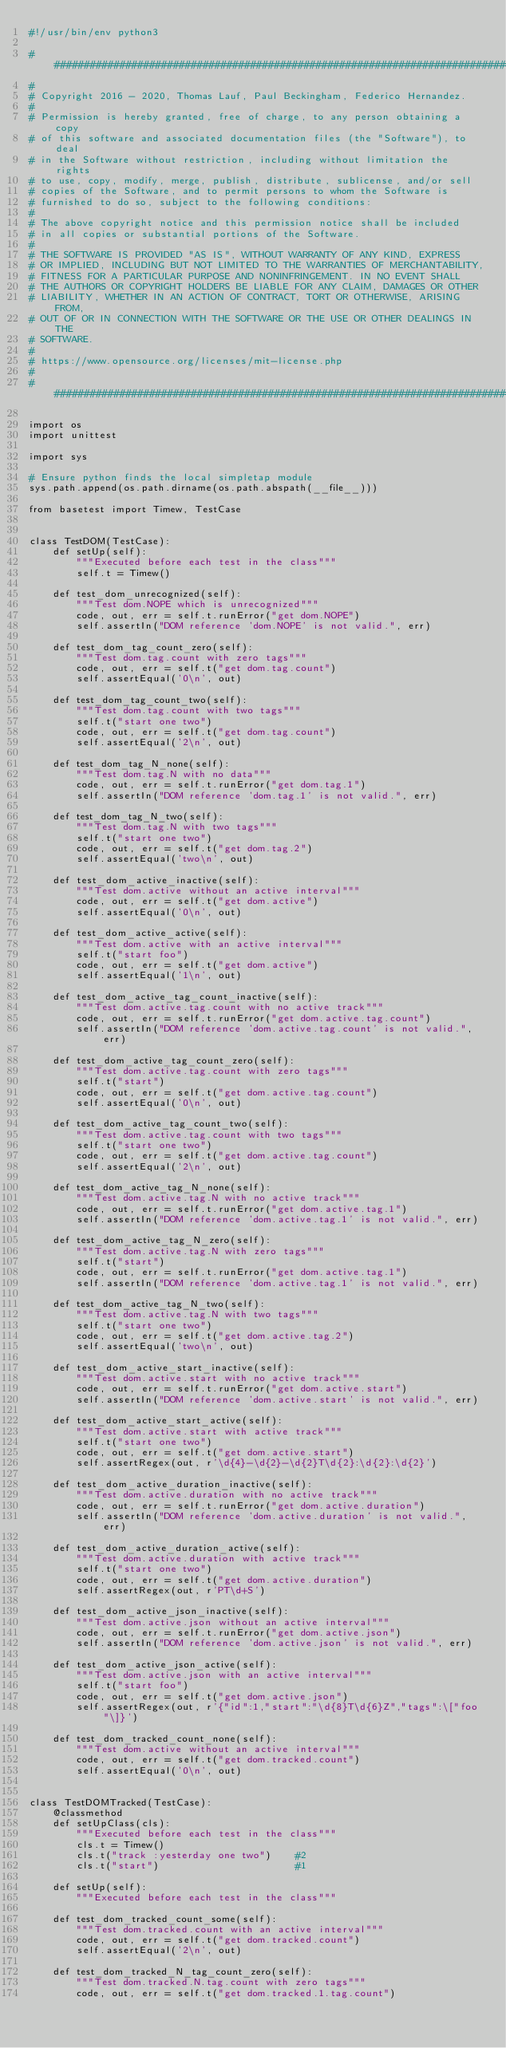<code> <loc_0><loc_0><loc_500><loc_500><_Perl_>#!/usr/bin/env python3

###############################################################################
#
# Copyright 2016 - 2020, Thomas Lauf, Paul Beckingham, Federico Hernandez.
#
# Permission is hereby granted, free of charge, to any person obtaining a copy
# of this software and associated documentation files (the "Software"), to deal
# in the Software without restriction, including without limitation the rights
# to use, copy, modify, merge, publish, distribute, sublicense, and/or sell
# copies of the Software, and to permit persons to whom the Software is
# furnished to do so, subject to the following conditions:
#
# The above copyright notice and this permission notice shall be included
# in all copies or substantial portions of the Software.
#
# THE SOFTWARE IS PROVIDED "AS IS", WITHOUT WARRANTY OF ANY KIND, EXPRESS
# OR IMPLIED, INCLUDING BUT NOT LIMITED TO THE WARRANTIES OF MERCHANTABILITY,
# FITNESS FOR A PARTICULAR PURPOSE AND NONINFRINGEMENT. IN NO EVENT SHALL
# THE AUTHORS OR COPYRIGHT HOLDERS BE LIABLE FOR ANY CLAIM, DAMAGES OR OTHER
# LIABILITY, WHETHER IN AN ACTION OF CONTRACT, TORT OR OTHERWISE, ARISING FROM,
# OUT OF OR IN CONNECTION WITH THE SOFTWARE OR THE USE OR OTHER DEALINGS IN THE
# SOFTWARE.
#
# https://www.opensource.org/licenses/mit-license.php
#
###############################################################################

import os
import unittest

import sys

# Ensure python finds the local simpletap module
sys.path.append(os.path.dirname(os.path.abspath(__file__)))

from basetest import Timew, TestCase


class TestDOM(TestCase):
    def setUp(self):
        """Executed before each test in the class"""
        self.t = Timew()

    def test_dom_unrecognized(self):
        """Test dom.NOPE which is unrecognized"""
        code, out, err = self.t.runError("get dom.NOPE")
        self.assertIn("DOM reference 'dom.NOPE' is not valid.", err)

    def test_dom_tag_count_zero(self):
        """Test dom.tag.count with zero tags"""
        code, out, err = self.t("get dom.tag.count")
        self.assertEqual('0\n', out)

    def test_dom_tag_count_two(self):
        """Test dom.tag.count with two tags"""
        self.t("start one two")
        code, out, err = self.t("get dom.tag.count")
        self.assertEqual('2\n', out)

    def test_dom_tag_N_none(self):
        """Test dom.tag.N with no data"""
        code, out, err = self.t.runError("get dom.tag.1")
        self.assertIn("DOM reference 'dom.tag.1' is not valid.", err)

    def test_dom_tag_N_two(self):
        """Test dom.tag.N with two tags"""
        self.t("start one two")
        code, out, err = self.t("get dom.tag.2")
        self.assertEqual('two\n', out)

    def test_dom_active_inactive(self):
        """Test dom.active without an active interval"""
        code, out, err = self.t("get dom.active")
        self.assertEqual('0\n', out)

    def test_dom_active_active(self):
        """Test dom.active with an active interval"""
        self.t("start foo")
        code, out, err = self.t("get dom.active")
        self.assertEqual('1\n', out)

    def test_dom_active_tag_count_inactive(self):
        """Test dom.active.tag.count with no active track"""
        code, out, err = self.t.runError("get dom.active.tag.count")
        self.assertIn("DOM reference 'dom.active.tag.count' is not valid.", err)

    def test_dom_active_tag_count_zero(self):
        """Test dom.active.tag.count with zero tags"""
        self.t("start")
        code, out, err = self.t("get dom.active.tag.count")
        self.assertEqual('0\n', out)

    def test_dom_active_tag_count_two(self):
        """Test dom.active.tag.count with two tags"""
        self.t("start one two")
        code, out, err = self.t("get dom.active.tag.count")
        self.assertEqual('2\n', out)

    def test_dom_active_tag_N_none(self):
        """Test dom.active.tag.N with no active track"""
        code, out, err = self.t.runError("get dom.active.tag.1")
        self.assertIn("DOM reference 'dom.active.tag.1' is not valid.", err)

    def test_dom_active_tag_N_zero(self):
        """Test dom.active.tag.N with zero tags"""
        self.t("start")
        code, out, err = self.t.runError("get dom.active.tag.1")
        self.assertIn("DOM reference 'dom.active.tag.1' is not valid.", err)

    def test_dom_active_tag_N_two(self):
        """Test dom.active.tag.N with two tags"""
        self.t("start one two")
        code, out, err = self.t("get dom.active.tag.2")
        self.assertEqual('two\n', out)

    def test_dom_active_start_inactive(self):
        """Test dom.active.start with no active track"""
        code, out, err = self.t.runError("get dom.active.start")
        self.assertIn("DOM reference 'dom.active.start' is not valid.", err)

    def test_dom_active_start_active(self):
        """Test dom.active.start with active track"""
        self.t("start one two")
        code, out, err = self.t("get dom.active.start")
        self.assertRegex(out, r'\d{4}-\d{2}-\d{2}T\d{2}:\d{2}:\d{2}')

    def test_dom_active_duration_inactive(self):
        """Test dom.active.duration with no active track"""
        code, out, err = self.t.runError("get dom.active.duration")
        self.assertIn("DOM reference 'dom.active.duration' is not valid.", err)

    def test_dom_active_duration_active(self):
        """Test dom.active.duration with active track"""
        self.t("start one two")
        code, out, err = self.t("get dom.active.duration")
        self.assertRegex(out, r'PT\d+S')

    def test_dom_active_json_inactive(self):
        """Test dom.active.json without an active interval"""
        code, out, err = self.t.runError("get dom.active.json")
        self.assertIn("DOM reference 'dom.active.json' is not valid.", err)

    def test_dom_active_json_active(self):
        """Test dom.active.json with an active interval"""
        self.t("start foo")
        code, out, err = self.t("get dom.active.json")
        self.assertRegex(out, r'{"id":1,"start":"\d{8}T\d{6}Z","tags":\["foo"\]}')

    def test_dom_tracked_count_none(self):
        """Test dom.active without an active interval"""
        code, out, err = self.t("get dom.tracked.count")
        self.assertEqual('0\n', out)


class TestDOMTracked(TestCase):
    @classmethod
    def setUpClass(cls):
        """Executed before each test in the class"""
        cls.t = Timew()
        cls.t("track :yesterday one two")    #2
        cls.t("start")                       #1

    def setUp(self):
        """Executed before each test in the class"""

    def test_dom_tracked_count_some(self):
        """Test dom.tracked.count with an active interval"""
        code, out, err = self.t("get dom.tracked.count")
        self.assertEqual('2\n', out)

    def test_dom_tracked_N_tag_count_zero(self):
        """Test dom.tracked.N.tag.count with zero tags"""
        code, out, err = self.t("get dom.tracked.1.tag.count")</code> 